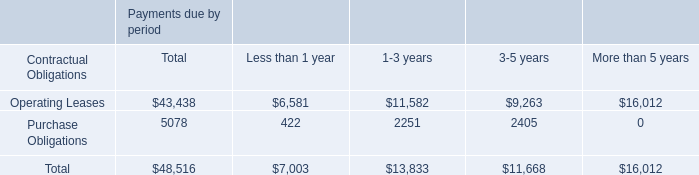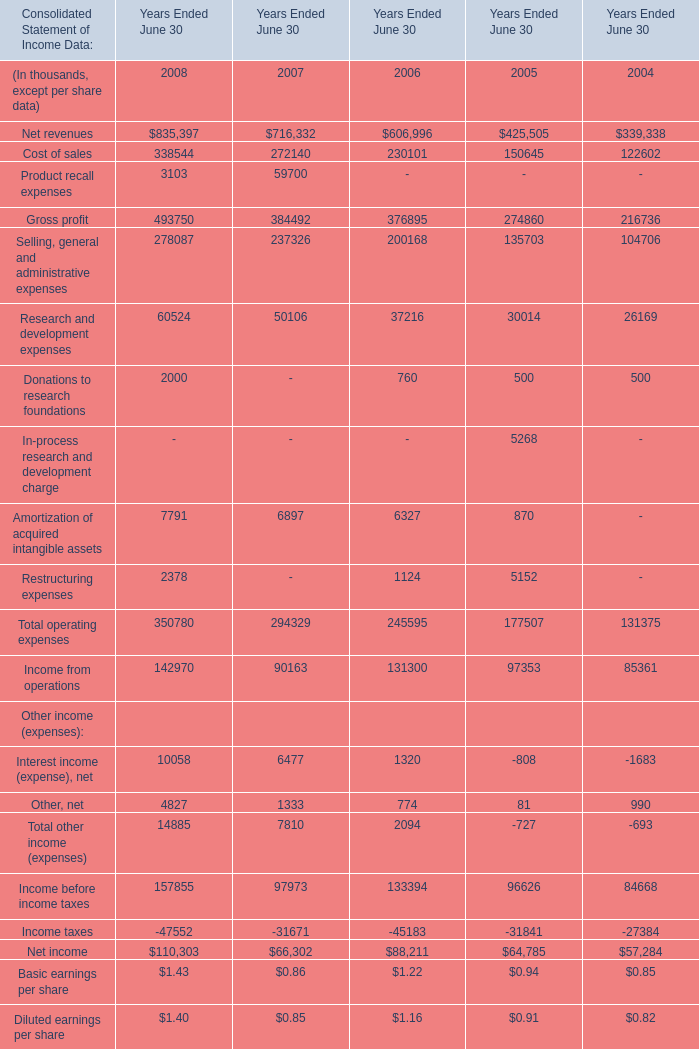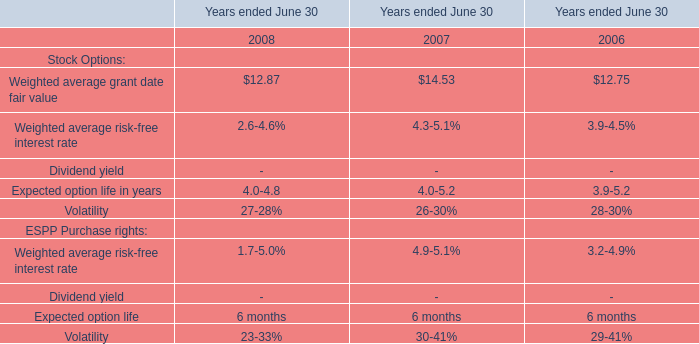What's the sum of Volatility of Years ended June 30 2006, Research and development expenses of Years Ended June 30 2006, and Total operating expenses of Years Ended June 30 2006 ? 
Computations: ((2830.0 + 37216.0) + 245595.0)
Answer: 285641.0. 